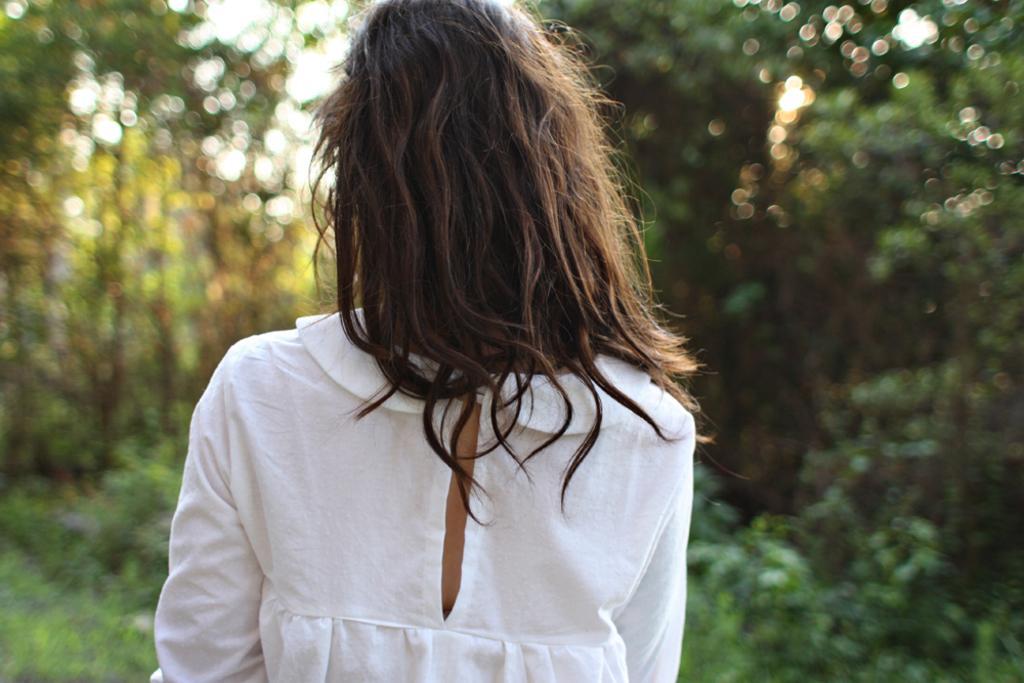How would you summarize this image in a sentence or two? A woman is there she wore white color dress, there are green trees at the back side of an image. 